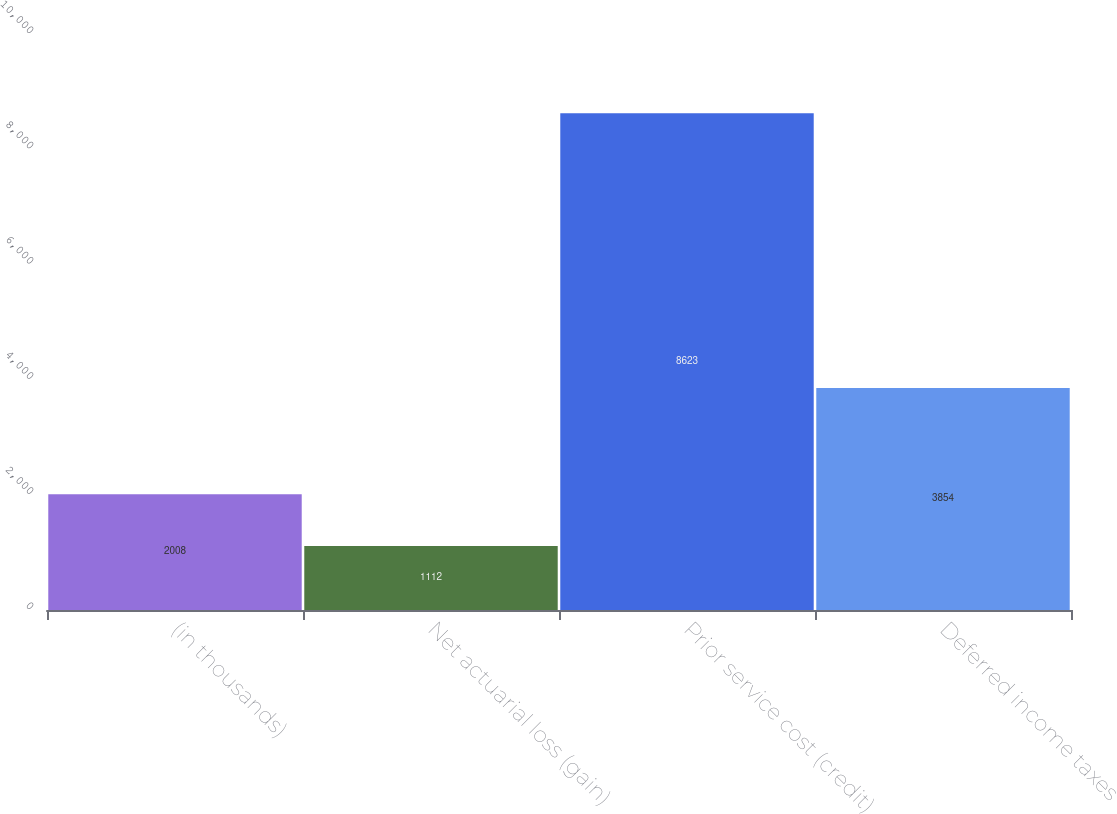Convert chart to OTSL. <chart><loc_0><loc_0><loc_500><loc_500><bar_chart><fcel>(in thousands)<fcel>Net actuarial loss (gain)<fcel>Prior service cost (credit)<fcel>Deferred income taxes<nl><fcel>2008<fcel>1112<fcel>8623<fcel>3854<nl></chart> 